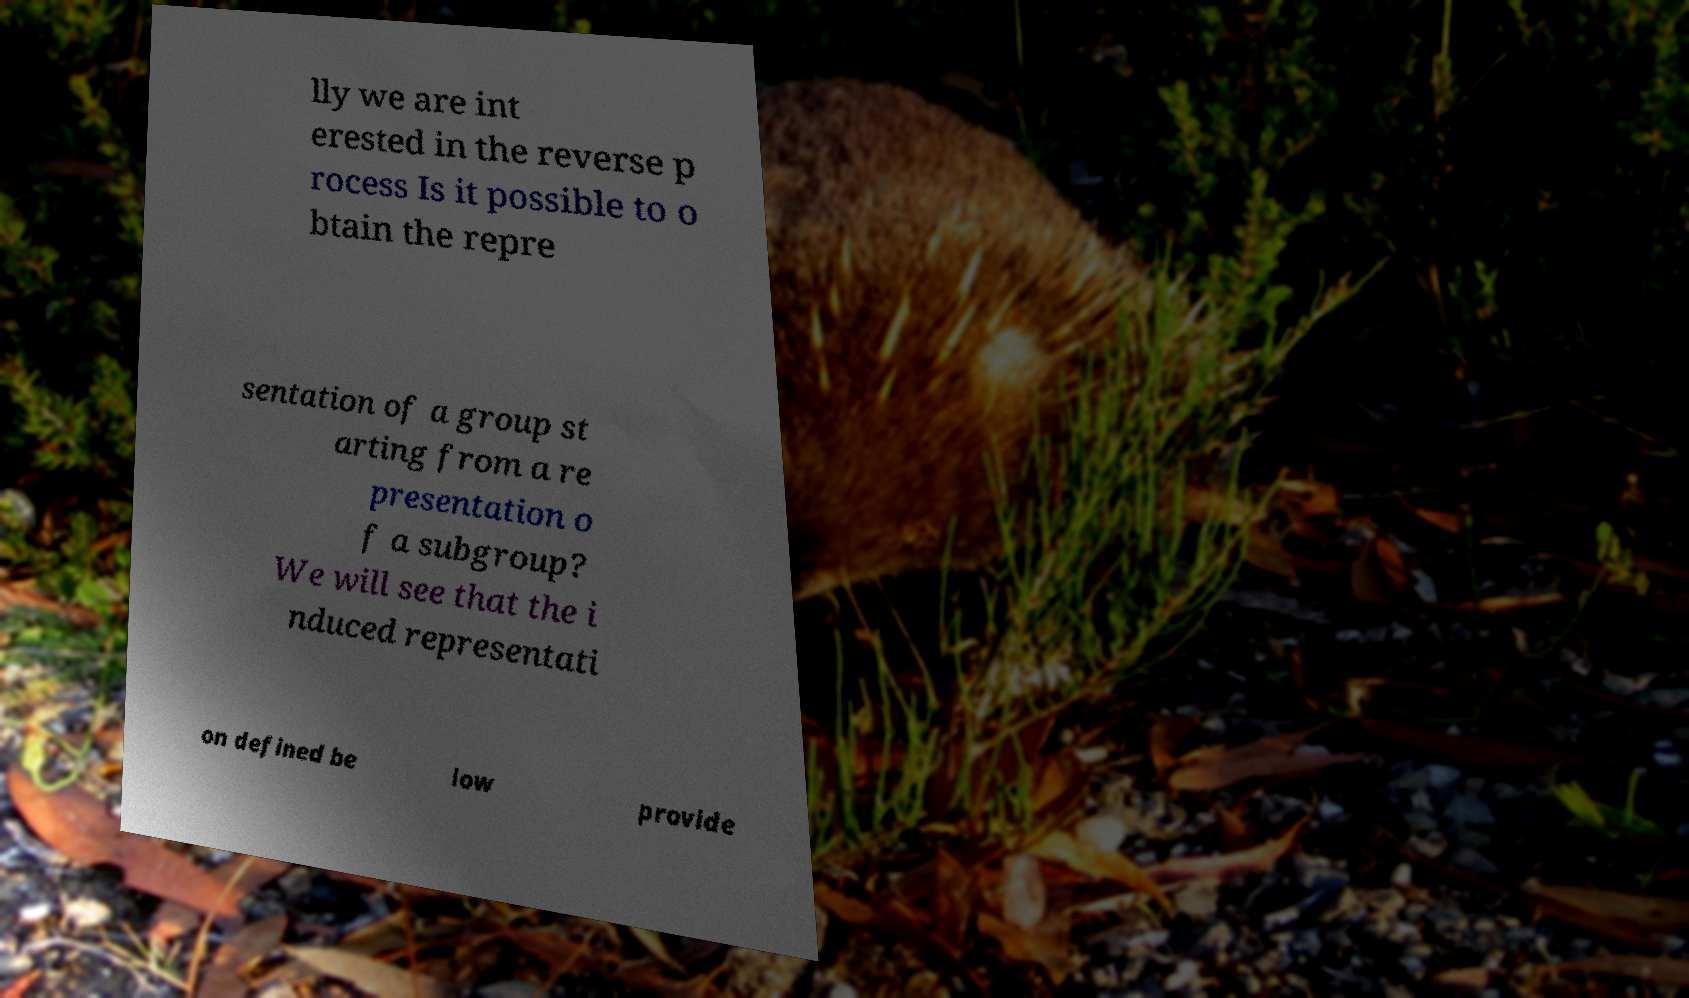Please identify and transcribe the text found in this image. lly we are int erested in the reverse p rocess Is it possible to o btain the repre sentation of a group st arting from a re presentation o f a subgroup? We will see that the i nduced representati on defined be low provide 